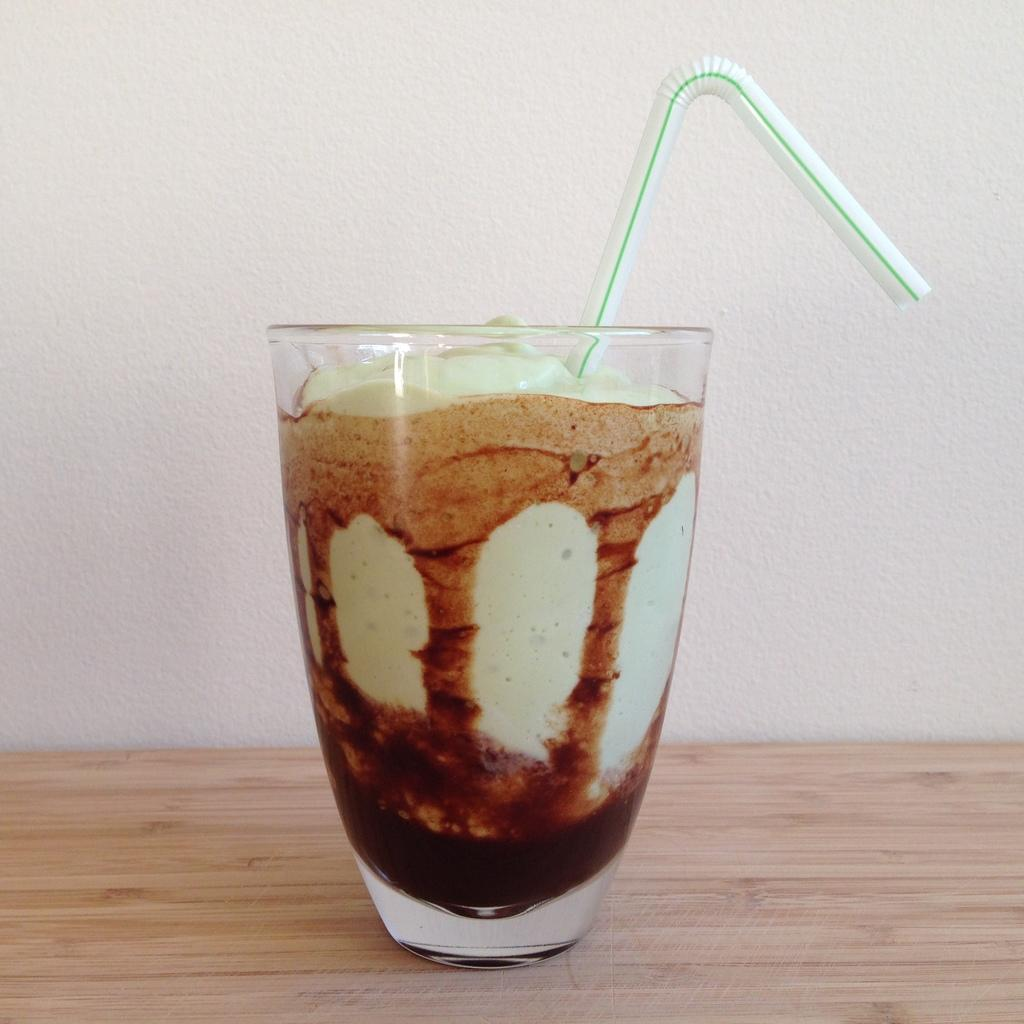What is inside the glass that is visible in the image? There is a straw in the glass. Where is the glass placed in the image? The glass is placed on a table. What can be seen in the background of the image? There is a wall in the background of the image. What type of sock is hanging from the wall in the image? There is no sock present in the image; only a glass with a straw and a wall are visible. 